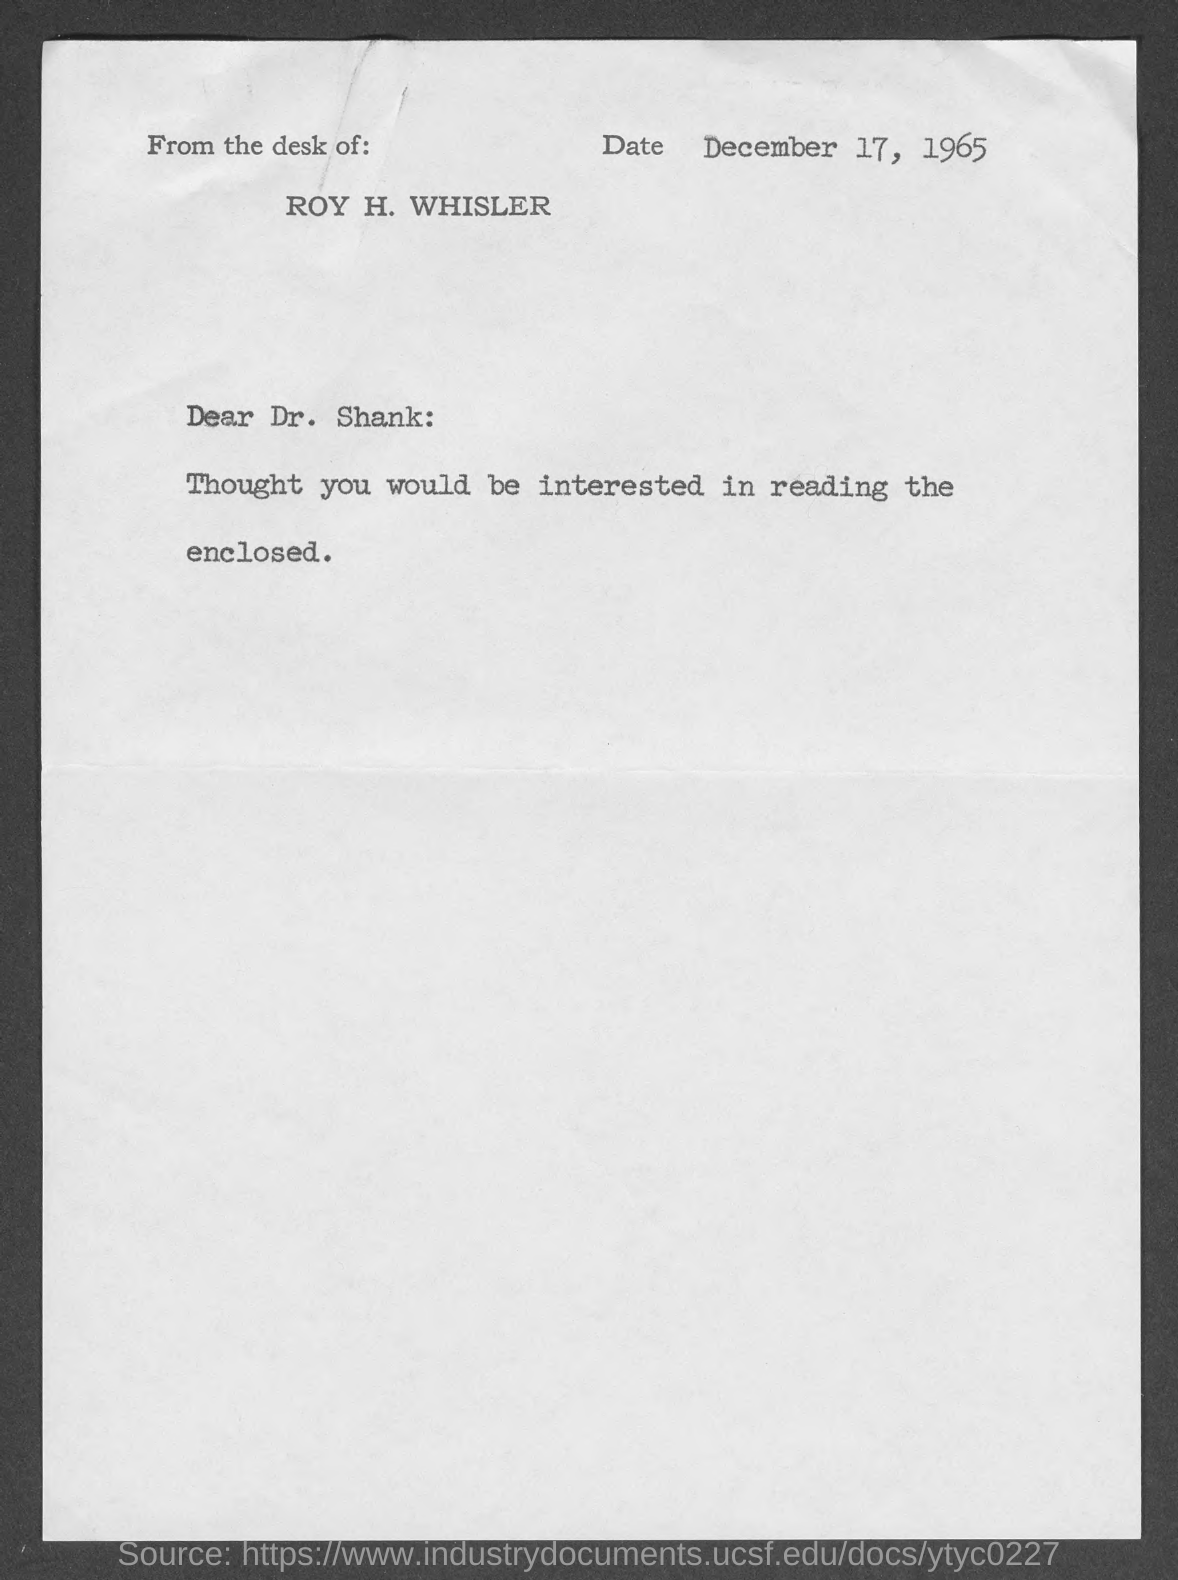Outline some significant characteristics in this image. The salutation of the letter is "Dear Dr. Shank:... The date is December 17, 1965. 